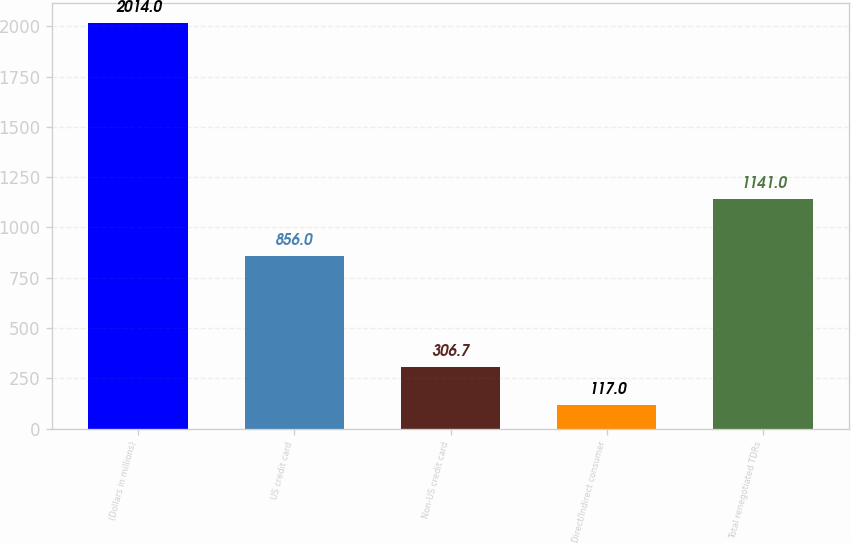Convert chart to OTSL. <chart><loc_0><loc_0><loc_500><loc_500><bar_chart><fcel>(Dollars in millions)<fcel>US credit card<fcel>Non-US credit card<fcel>Direct/Indirect consumer<fcel>Total renegotiated TDRs<nl><fcel>2014<fcel>856<fcel>306.7<fcel>117<fcel>1141<nl></chart> 